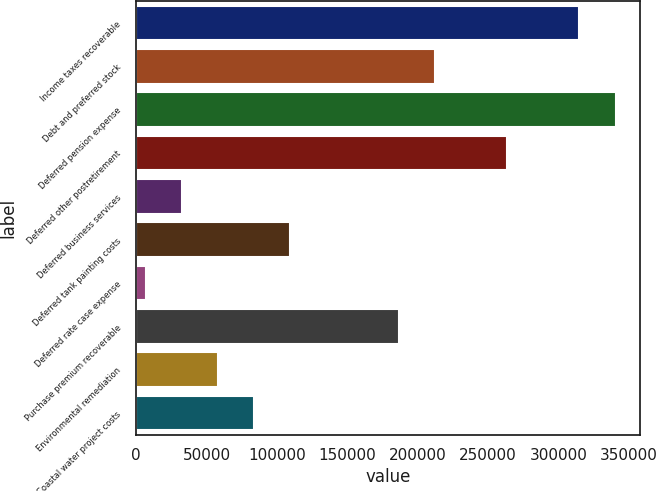Convert chart. <chart><loc_0><loc_0><loc_500><loc_500><bar_chart><fcel>Income taxes recoverable<fcel>Debt and preferred stock<fcel>Deferred pension expense<fcel>Deferred other postretirement<fcel>Deferred business services<fcel>Deferred tank painting costs<fcel>Deferred rate case expense<fcel>Purchase premium recoverable<fcel>Environmental remediation<fcel>Coastal water project costs<nl><fcel>314826<fcel>212146<fcel>340496<fcel>263486<fcel>32455.1<fcel>109465<fcel>6785<fcel>186476<fcel>58125.2<fcel>83795.3<nl></chart> 